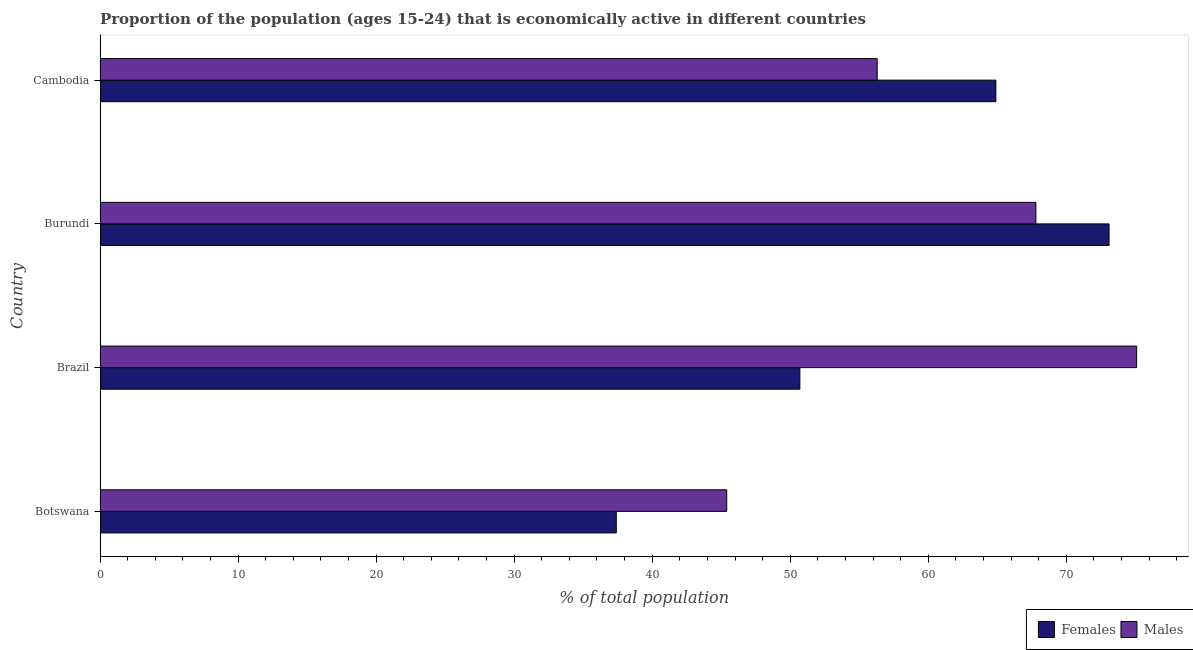Are the number of bars on each tick of the Y-axis equal?
Give a very brief answer. Yes. What is the label of the 2nd group of bars from the top?
Your answer should be compact. Burundi. In how many cases, is the number of bars for a given country not equal to the number of legend labels?
Make the answer very short. 0. What is the percentage of economically active male population in Burundi?
Provide a succinct answer. 67.8. Across all countries, what is the maximum percentage of economically active male population?
Provide a succinct answer. 75.1. Across all countries, what is the minimum percentage of economically active female population?
Ensure brevity in your answer.  37.4. In which country was the percentage of economically active male population minimum?
Ensure brevity in your answer.  Botswana. What is the total percentage of economically active male population in the graph?
Ensure brevity in your answer.  244.6. What is the difference between the percentage of economically active female population in Botswana and that in Burundi?
Ensure brevity in your answer.  -35.7. What is the difference between the percentage of economically active male population in Burundi and the percentage of economically active female population in Brazil?
Offer a terse response. 17.1. What is the average percentage of economically active female population per country?
Your answer should be very brief. 56.52. What is the difference between the percentage of economically active female population and percentage of economically active male population in Botswana?
Offer a terse response. -8. What is the ratio of the percentage of economically active female population in Brazil to that in Burundi?
Provide a succinct answer. 0.69. Is the percentage of economically active male population in Botswana less than that in Brazil?
Keep it short and to the point. Yes. What is the difference between the highest and the second highest percentage of economically active female population?
Your answer should be very brief. 8.2. What is the difference between the highest and the lowest percentage of economically active male population?
Your response must be concise. 29.7. Is the sum of the percentage of economically active male population in Burundi and Cambodia greater than the maximum percentage of economically active female population across all countries?
Ensure brevity in your answer.  Yes. What does the 1st bar from the top in Burundi represents?
Offer a very short reply. Males. What does the 1st bar from the bottom in Brazil represents?
Offer a very short reply. Females. Are all the bars in the graph horizontal?
Make the answer very short. Yes. Does the graph contain grids?
Your response must be concise. No. Where does the legend appear in the graph?
Offer a terse response. Bottom right. How many legend labels are there?
Your answer should be compact. 2. How are the legend labels stacked?
Your answer should be compact. Horizontal. What is the title of the graph?
Make the answer very short. Proportion of the population (ages 15-24) that is economically active in different countries. What is the label or title of the X-axis?
Offer a terse response. % of total population. What is the % of total population in Females in Botswana?
Offer a very short reply. 37.4. What is the % of total population of Males in Botswana?
Provide a succinct answer. 45.4. What is the % of total population of Females in Brazil?
Keep it short and to the point. 50.7. What is the % of total population of Males in Brazil?
Your answer should be compact. 75.1. What is the % of total population in Females in Burundi?
Offer a very short reply. 73.1. What is the % of total population in Males in Burundi?
Offer a very short reply. 67.8. What is the % of total population in Females in Cambodia?
Give a very brief answer. 64.9. What is the % of total population of Males in Cambodia?
Offer a very short reply. 56.3. Across all countries, what is the maximum % of total population in Females?
Provide a succinct answer. 73.1. Across all countries, what is the maximum % of total population in Males?
Your answer should be compact. 75.1. Across all countries, what is the minimum % of total population in Females?
Provide a short and direct response. 37.4. Across all countries, what is the minimum % of total population of Males?
Your response must be concise. 45.4. What is the total % of total population of Females in the graph?
Your response must be concise. 226.1. What is the total % of total population of Males in the graph?
Ensure brevity in your answer.  244.6. What is the difference between the % of total population of Females in Botswana and that in Brazil?
Your answer should be very brief. -13.3. What is the difference between the % of total population of Males in Botswana and that in Brazil?
Your answer should be very brief. -29.7. What is the difference between the % of total population in Females in Botswana and that in Burundi?
Keep it short and to the point. -35.7. What is the difference between the % of total population of Males in Botswana and that in Burundi?
Your answer should be compact. -22.4. What is the difference between the % of total population of Females in Botswana and that in Cambodia?
Your answer should be compact. -27.5. What is the difference between the % of total population of Females in Brazil and that in Burundi?
Your answer should be compact. -22.4. What is the difference between the % of total population in Males in Brazil and that in Burundi?
Offer a very short reply. 7.3. What is the difference between the % of total population of Males in Brazil and that in Cambodia?
Offer a very short reply. 18.8. What is the difference between the % of total population of Females in Burundi and that in Cambodia?
Make the answer very short. 8.2. What is the difference between the % of total population of Females in Botswana and the % of total population of Males in Brazil?
Your response must be concise. -37.7. What is the difference between the % of total population of Females in Botswana and the % of total population of Males in Burundi?
Offer a terse response. -30.4. What is the difference between the % of total population in Females in Botswana and the % of total population in Males in Cambodia?
Offer a very short reply. -18.9. What is the difference between the % of total population in Females in Brazil and the % of total population in Males in Burundi?
Your answer should be compact. -17.1. What is the difference between the % of total population of Females in Brazil and the % of total population of Males in Cambodia?
Your answer should be compact. -5.6. What is the average % of total population of Females per country?
Your response must be concise. 56.52. What is the average % of total population in Males per country?
Keep it short and to the point. 61.15. What is the difference between the % of total population of Females and % of total population of Males in Brazil?
Make the answer very short. -24.4. What is the difference between the % of total population in Females and % of total population in Males in Burundi?
Offer a very short reply. 5.3. What is the ratio of the % of total population in Females in Botswana to that in Brazil?
Your response must be concise. 0.74. What is the ratio of the % of total population in Males in Botswana to that in Brazil?
Give a very brief answer. 0.6. What is the ratio of the % of total population of Females in Botswana to that in Burundi?
Your answer should be very brief. 0.51. What is the ratio of the % of total population of Males in Botswana to that in Burundi?
Provide a short and direct response. 0.67. What is the ratio of the % of total population of Females in Botswana to that in Cambodia?
Ensure brevity in your answer.  0.58. What is the ratio of the % of total population of Males in Botswana to that in Cambodia?
Your answer should be compact. 0.81. What is the ratio of the % of total population of Females in Brazil to that in Burundi?
Offer a very short reply. 0.69. What is the ratio of the % of total population of Males in Brazil to that in Burundi?
Provide a succinct answer. 1.11. What is the ratio of the % of total population in Females in Brazil to that in Cambodia?
Your answer should be compact. 0.78. What is the ratio of the % of total population of Males in Brazil to that in Cambodia?
Make the answer very short. 1.33. What is the ratio of the % of total population of Females in Burundi to that in Cambodia?
Provide a short and direct response. 1.13. What is the ratio of the % of total population of Males in Burundi to that in Cambodia?
Offer a terse response. 1.2. What is the difference between the highest and the second highest % of total population in Females?
Ensure brevity in your answer.  8.2. What is the difference between the highest and the second highest % of total population of Males?
Provide a short and direct response. 7.3. What is the difference between the highest and the lowest % of total population of Females?
Provide a short and direct response. 35.7. What is the difference between the highest and the lowest % of total population of Males?
Offer a terse response. 29.7. 